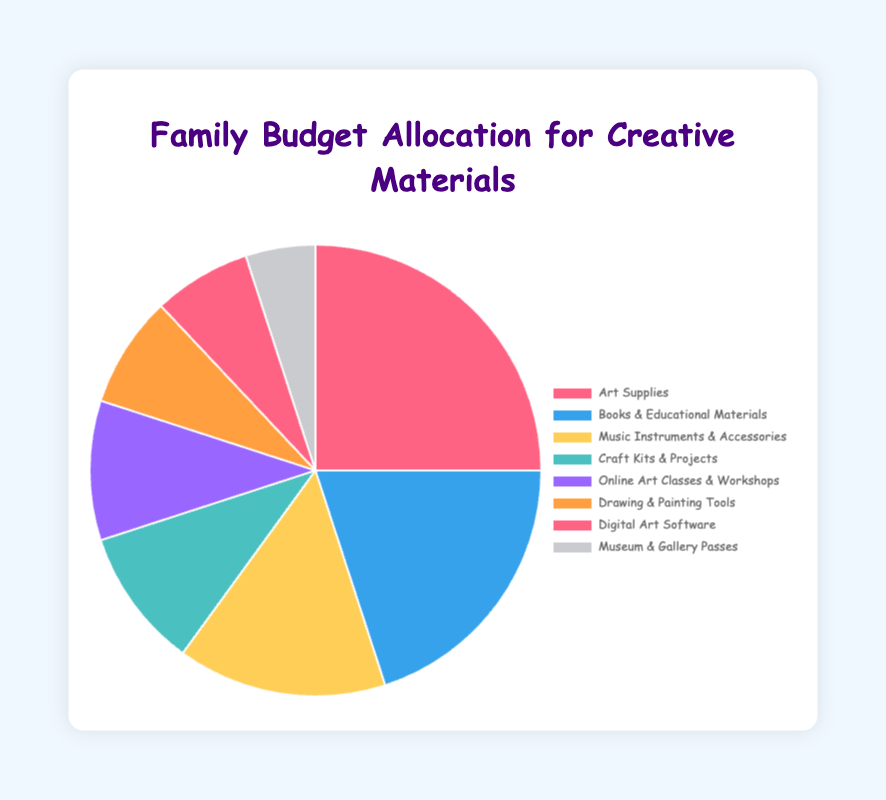What percentage of the family budget is allocated to Art Supplies? From the pie chart, the section labeled "Art Supplies" shows a 25% allocation.
Answer: 25% Is the allocation for Books & Educational Materials greater than for Craft Kits & Projects? Yes, by referring to the chart, Books & Educational Materials is allocated 20%, whereas Craft Kits & Projects is allocated 10%.
Answer: Yes What is the total percentage allocated to Online Art Classes & Workshops and Digital Art Software combined? Adding the percentages for Online Art Classes & Workshops (10%) and Digital Art Software (7%) gives a total of 17%.
Answer: 17% Which category has the smallest allocation in the family budget? By looking at the pie chart, Museum & Gallery Passes has the smallest slice, with an allocation of 5%.
Answer: Museum & Gallery Passes How much more is allocated to Music Instruments & Accessories compared to Drawing & Painting Tools? The percentage for Music Instruments & Accessories is 15%, while Drawing & Painting Tools is 8%. The difference is 15% - 8% = 7%.
Answer: 7% What visual color represents the category with the highest budget allocation? The category with the highest allocation is Art Supplies, which is represented in red on the pie chart.
Answer: Red Calculate the average allocation for all categories displayed in the pie chart. Sum all percentages: 25 + 20 + 15 + 10 + 10 + 8 + 7 + 5 = 100. There are 8 categories, so the average is 100 / 8 = 12.5%.
Answer: 12.5% Is the allocation for Art Supplies and Books & Educational Materials together more than half of the total budget? The combined allocation for Art Supplies (25%) and Books & Educational Materials (20%) is 25% + 20% = 45%, which is less than half the total budget of 100%.
Answer: No If the family reallocates 5% from Craft Kits & Projects to Drawing & Painting Tools, what would be the new allocation for Drawing & Painting Tools? Currently, Drawing & Painting Tools have 8%. After adding 5% reallocated from Craft Kits & Projects, it will be 8% + 5% = 13%.
Answer: 13% 